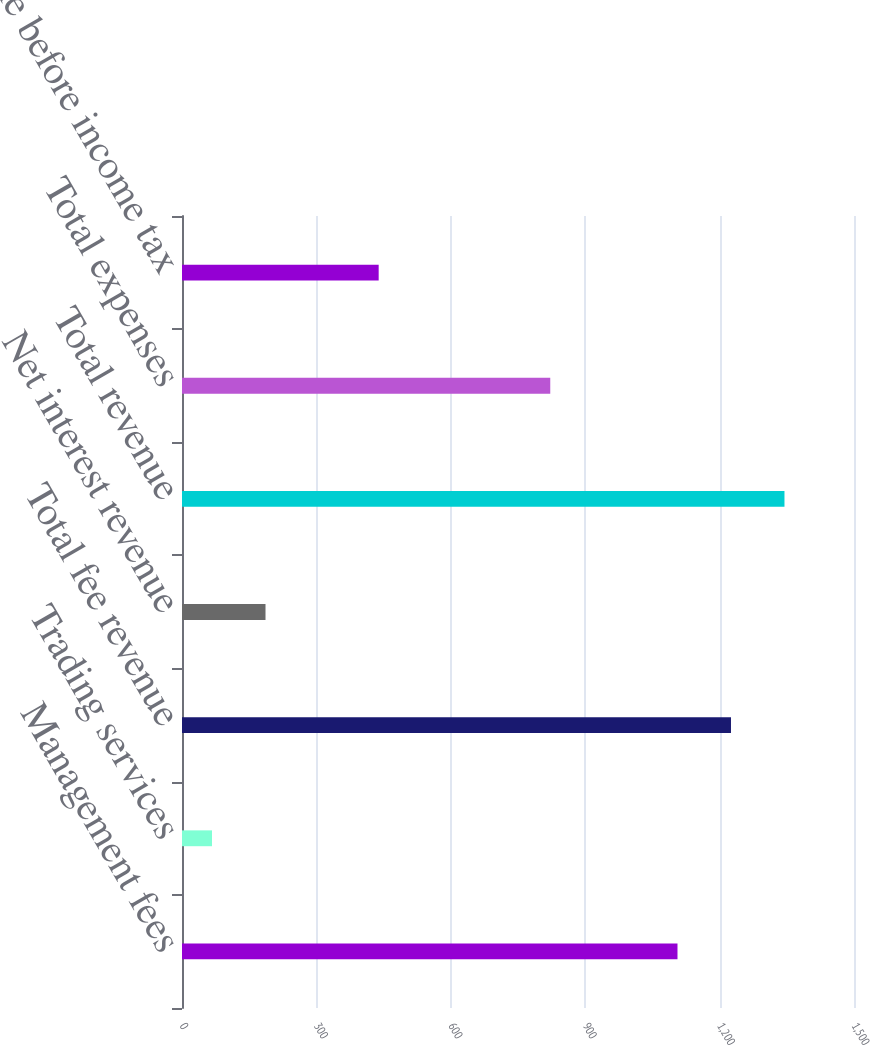Convert chart to OTSL. <chart><loc_0><loc_0><loc_500><loc_500><bar_chart><fcel>Management fees<fcel>Trading services<fcel>Total fee revenue<fcel>Net interest revenue<fcel>Total revenue<fcel>Total expenses<fcel>Income before income tax<nl><fcel>1106<fcel>67<fcel>1225.4<fcel>186.4<fcel>1344.8<fcel>822<fcel>439<nl></chart> 